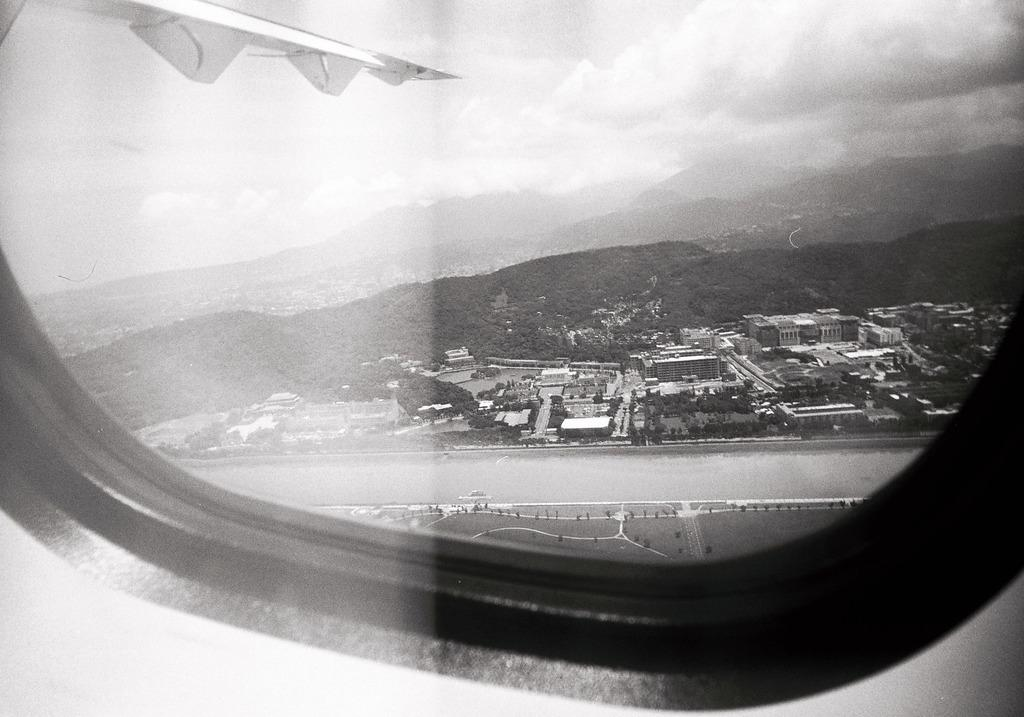What is located at the front of the image? There is a window in the front of the image. What can be seen through the window? Trees, buildings, and mountains are visible behind the window. What is the condition of the sky in the image? The sky is cloudy in the image. What type of profit can be seen in the image? There is no reference to profit in the image; it features a window with a view of trees, buildings, mountains, and a cloudy sky. 